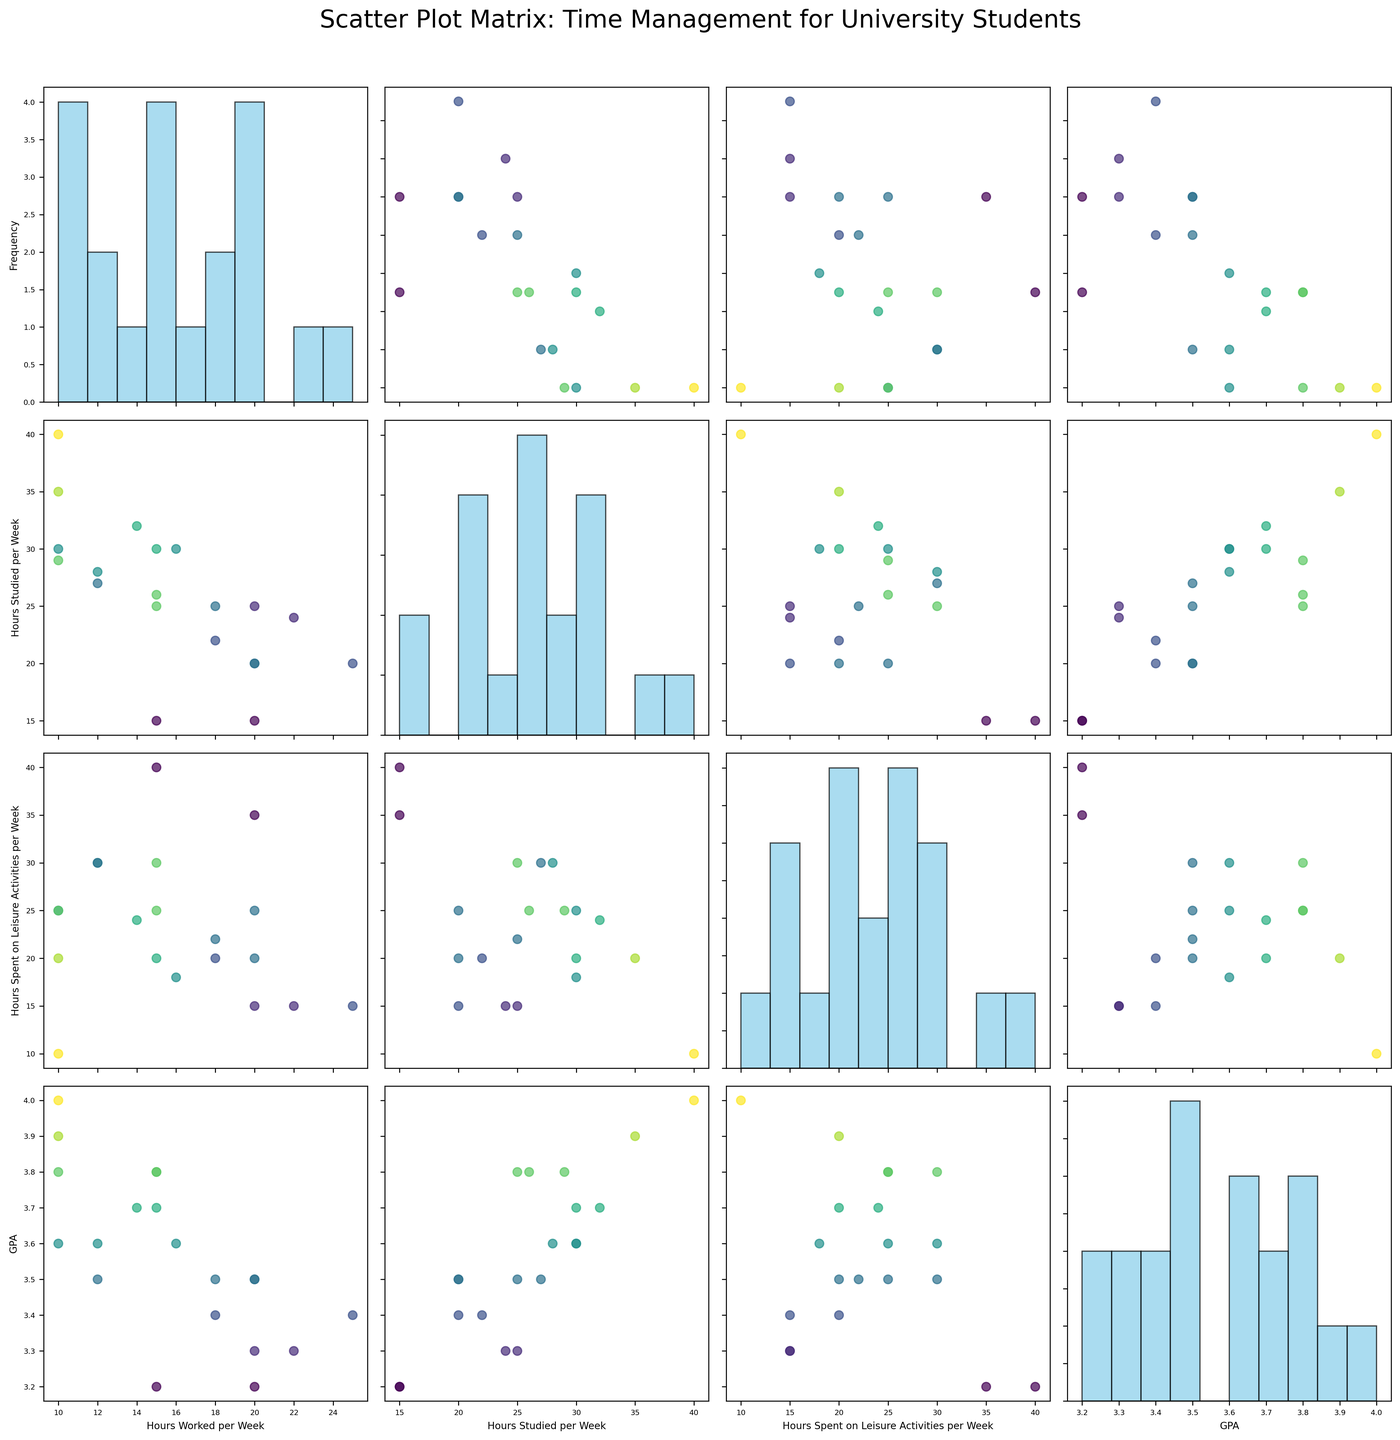What is the title of the scatter plot matrix? The title is usually placed at the top of the figure. By observing this particular scatter plot matrix, we can see the title clearly indicated.
Answer: Scatter Plot Matrix: Time Management for University Students How many variables are depicted in the scatter plot matrix? By counting the variables listed on both the x and y axes, we can see there are four elements.
Answer: Four Which variable seems to have the highest frequency for a specific value in its histogram? By examining the diagonal histogram plots, look for the histogram with the tallest bar. This indicates the highest frequency for a specific value.
Answer: Hours Studied per Week Is there a noticeable relationship between GPA and Hours Studied per Week? Look at the scatter plot where GPA is on one axis and Hours Studied per Week on the other. A positive trend line or clustering of high GPA with more study hours indicates a relationship.
Answer: Positive Relationship Which combination of variables shows the most dispersed scatter plot? Observe the scatter plots off the diagonal and identify the plot with the points spread out the most. This indicates high dispersion.
Answer: Hours Worked per Week vs. Hours Spent on Leisure Activities per Week What can be said about students who work more hours per week in terms of their GPA? Identify the scatter plot between Hours Worked per Week and GPA. Notice if there’s any clustering towards lower GPA values for higher work hours.
Answer: Lower GPA Is there any clustering of data points with respect to GPA? Look at the color gradient in the scatter plots, as the color represents GPA. Clustering by similar color indicates clustering with respect to GPA.
Answer: Yes Do students with higher GPAs tend to spend more time on leisure activities? Examine the scatter plot of GPA vs. Hours Spent on Leisure Activities per Week to see if higher GPA values correspond with higher leisure hours.
Answer: No clear trend Is there a apparent trade-off between Hours Studied per Week and Hours Spent on Leisure Activities per Week? Look at the scatter plot where these two variables are plotted against each other. A negative trend or lack of correlation may indicate a trade-off.
Answer: Possible trade-off What's the general trend between Hours Worked per Week and Hours Spent on Leisure Activities per Week? Examine the scatter plot where Hours Worked per Week is on one axis and Hours Spent on Leisure Activities per Week on the other. Observe for any visible trend lines.
Answer: Slight negative trend 